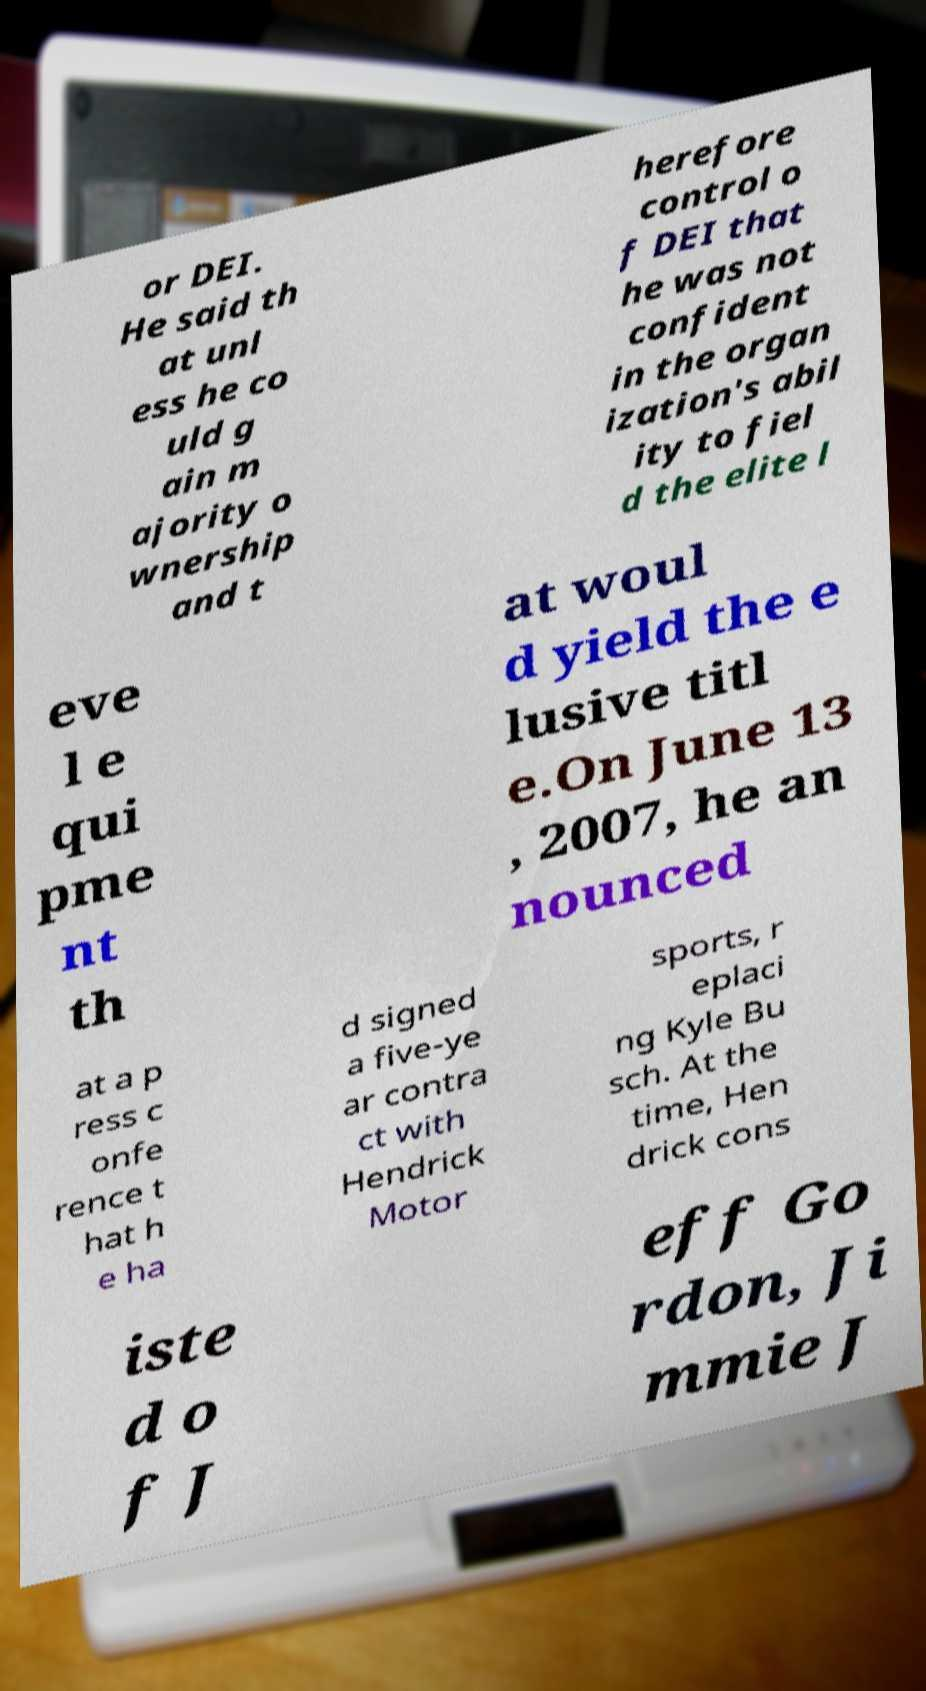Could you assist in decoding the text presented in this image and type it out clearly? or DEI. He said th at unl ess he co uld g ain m ajority o wnership and t herefore control o f DEI that he was not confident in the organ ization's abil ity to fiel d the elite l eve l e qui pme nt th at woul d yield the e lusive titl e.On June 13 , 2007, he an nounced at a p ress c onfe rence t hat h e ha d signed a five-ye ar contra ct with Hendrick Motor sports, r eplaci ng Kyle Bu sch. At the time, Hen drick cons iste d o f J eff Go rdon, Ji mmie J 